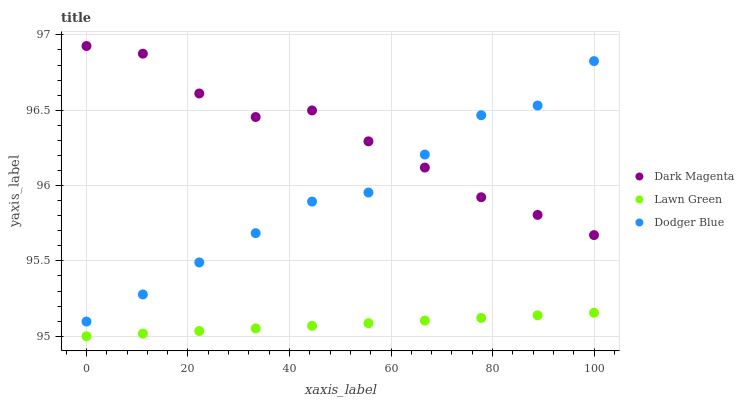Does Lawn Green have the minimum area under the curve?
Answer yes or no. Yes. Does Dark Magenta have the maximum area under the curve?
Answer yes or no. Yes. Does Dodger Blue have the minimum area under the curve?
Answer yes or no. No. Does Dodger Blue have the maximum area under the curve?
Answer yes or no. No. Is Lawn Green the smoothest?
Answer yes or no. Yes. Is Dark Magenta the roughest?
Answer yes or no. Yes. Is Dodger Blue the smoothest?
Answer yes or no. No. Is Dodger Blue the roughest?
Answer yes or no. No. Does Lawn Green have the lowest value?
Answer yes or no. Yes. Does Dodger Blue have the lowest value?
Answer yes or no. No. Does Dark Magenta have the highest value?
Answer yes or no. Yes. Does Dodger Blue have the highest value?
Answer yes or no. No. Is Lawn Green less than Dodger Blue?
Answer yes or no. Yes. Is Dark Magenta greater than Lawn Green?
Answer yes or no. Yes. Does Dodger Blue intersect Dark Magenta?
Answer yes or no. Yes. Is Dodger Blue less than Dark Magenta?
Answer yes or no. No. Is Dodger Blue greater than Dark Magenta?
Answer yes or no. No. Does Lawn Green intersect Dodger Blue?
Answer yes or no. No. 